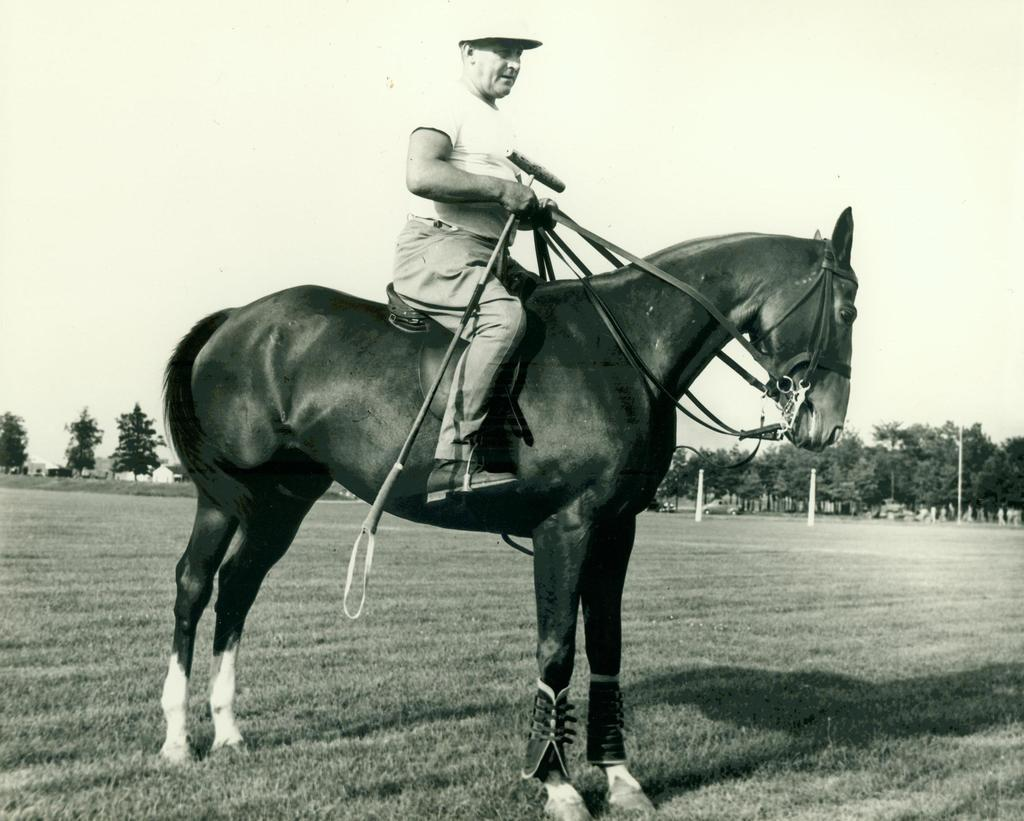What is the color scheme of the image? The image is black and white. What animal is present in the image? There is a horse in the image. What is the man on the horse doing? The man is sitting on the horse and holding a stick. What can be seen in the background of the image? There are trees in the background of the image. What type of oven is visible in the image? There is no oven present in the image. What is the horse's tendency in the image? The image does not show the horse's behavior or tendencies. 